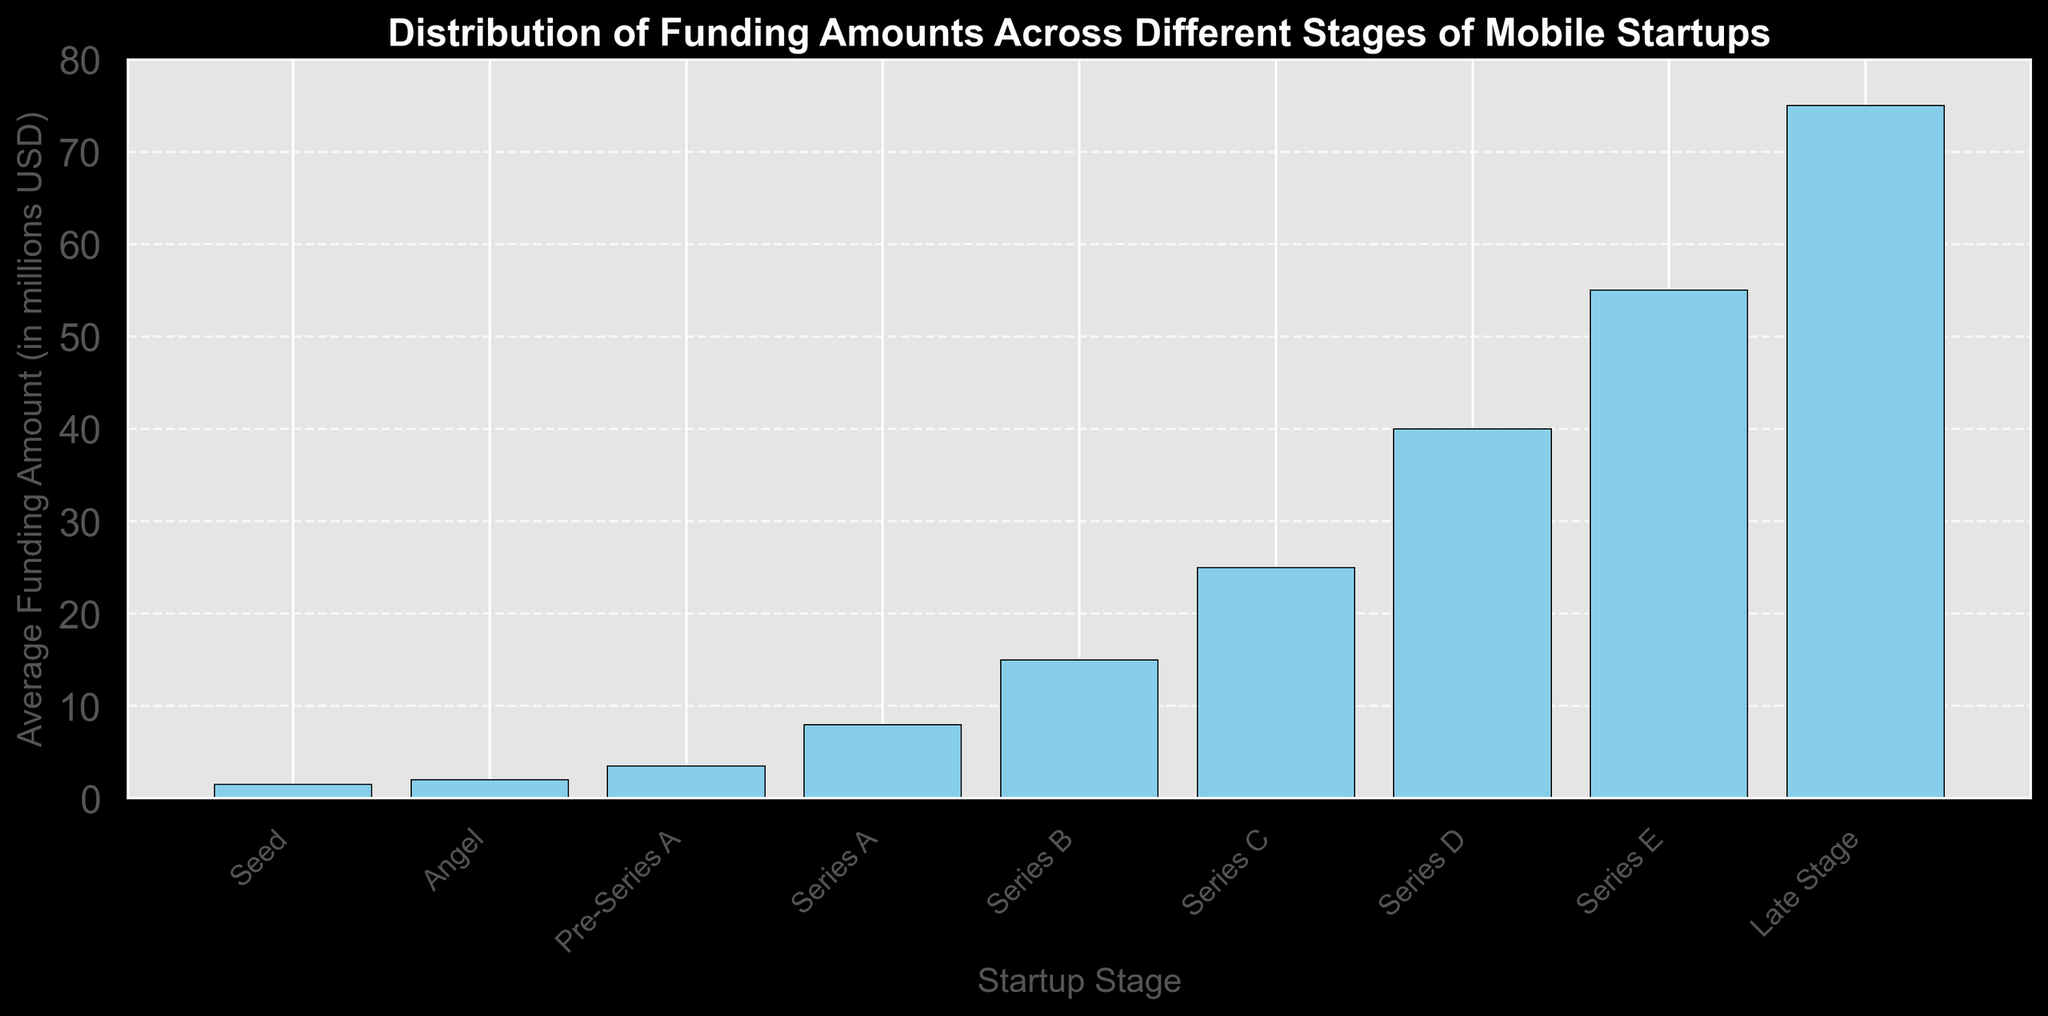What is the average funding amount for startups in the Seed stage? Locate the bar representing the Seed stage and observe its height, corresponding to the average funding amount.
Answer: 1.5 million USD Which stage has the highest average funding amount? Identify the tallest bar in the chart, which represents the stage with the highest average funding amount.
Answer: Late Stage Compare the average funding amounts between Series A and Series B. Which one is higher and by how much? Locate the bars for Series A and Series B. Identify their average funding amounts and subtract the value of Series A from Series B.
Answer: Series B is higher by 7 million USD What is the total average funding amount for the stages Angel, Pre-Series A, and Series A? Sum the heights of the bars corresponding to the Angel, Pre-Series A, and Series A stages.
Answer: 13.5 million USD Which stage(s) have an average funding amount of more than 30 million USD? Identify the bars whose height exceeds 30 million USD and note the corresponding stages.
Answer: Series D, Series E, Late Stage Is the funding amount in the Pre-Series A stage more or less than twice the amount in the Seed stage? Calculate twice the amount in the Seed stage (2 * 1.5) and compare it with the average funding amount of the Pre-Series A stage.
Answer: More How does the funding amount in Series C compare to that in Series D? Find the heights of the bars for Series C and Series D, and compare the values.
Answer: Series D is higher What is the difference in average funding amounts between the Angel stage and the Late Stage? Subtract the average funding amount of the Angel stage from that of the Late Stage.
Answer: 73 million USD Which stage has a funding amount closest to 50 million USD? Identify the bars and find which one has a height closest to 50 million USD.
Answer: Series E Calculate the average funding amount across all stages. Sum the average funding amounts for all stages, then divide by the number of stages: Sum = 225, Number of Stages = 9, Average = 225 / 9.
Answer: 25 million USD 